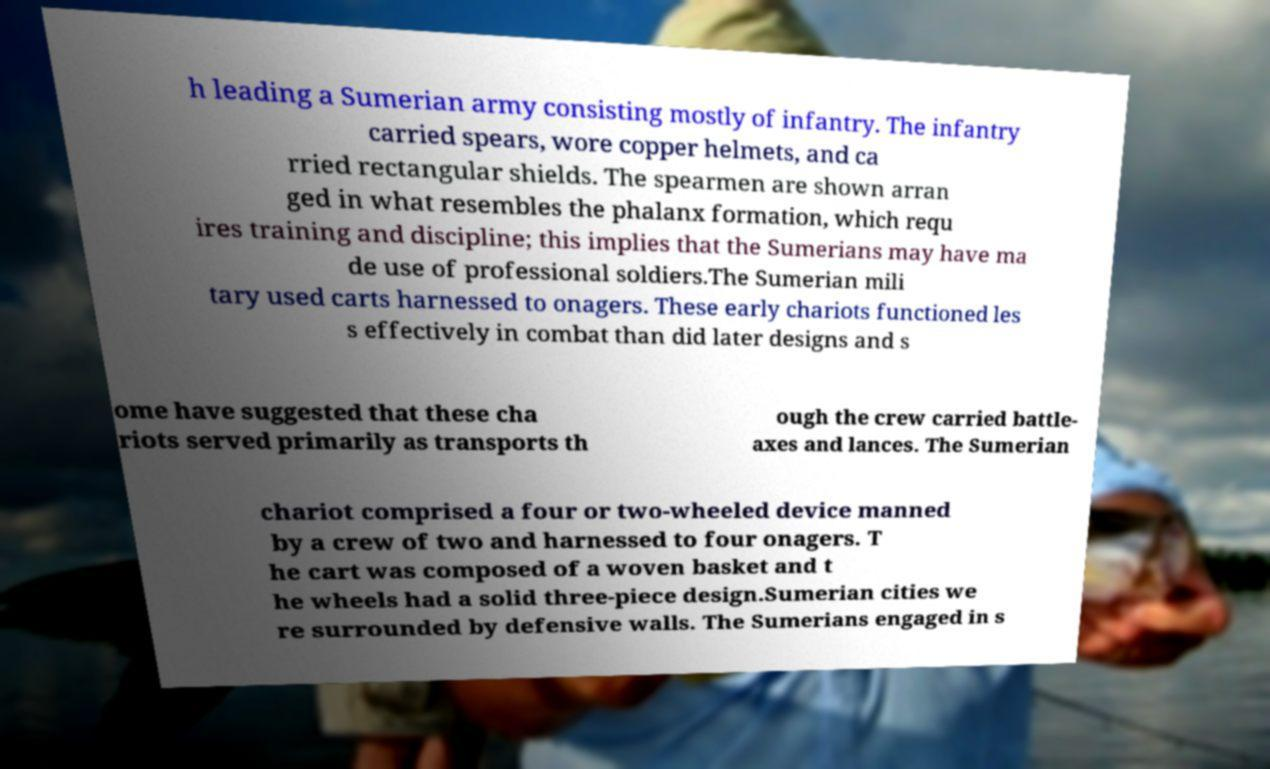Could you extract and type out the text from this image? h leading a Sumerian army consisting mostly of infantry. The infantry carried spears, wore copper helmets, and ca rried rectangular shields. The spearmen are shown arran ged in what resembles the phalanx formation, which requ ires training and discipline; this implies that the Sumerians may have ma de use of professional soldiers.The Sumerian mili tary used carts harnessed to onagers. These early chariots functioned les s effectively in combat than did later designs and s ome have suggested that these cha riots served primarily as transports th ough the crew carried battle- axes and lances. The Sumerian chariot comprised a four or two-wheeled device manned by a crew of two and harnessed to four onagers. T he cart was composed of a woven basket and t he wheels had a solid three-piece design.Sumerian cities we re surrounded by defensive walls. The Sumerians engaged in s 